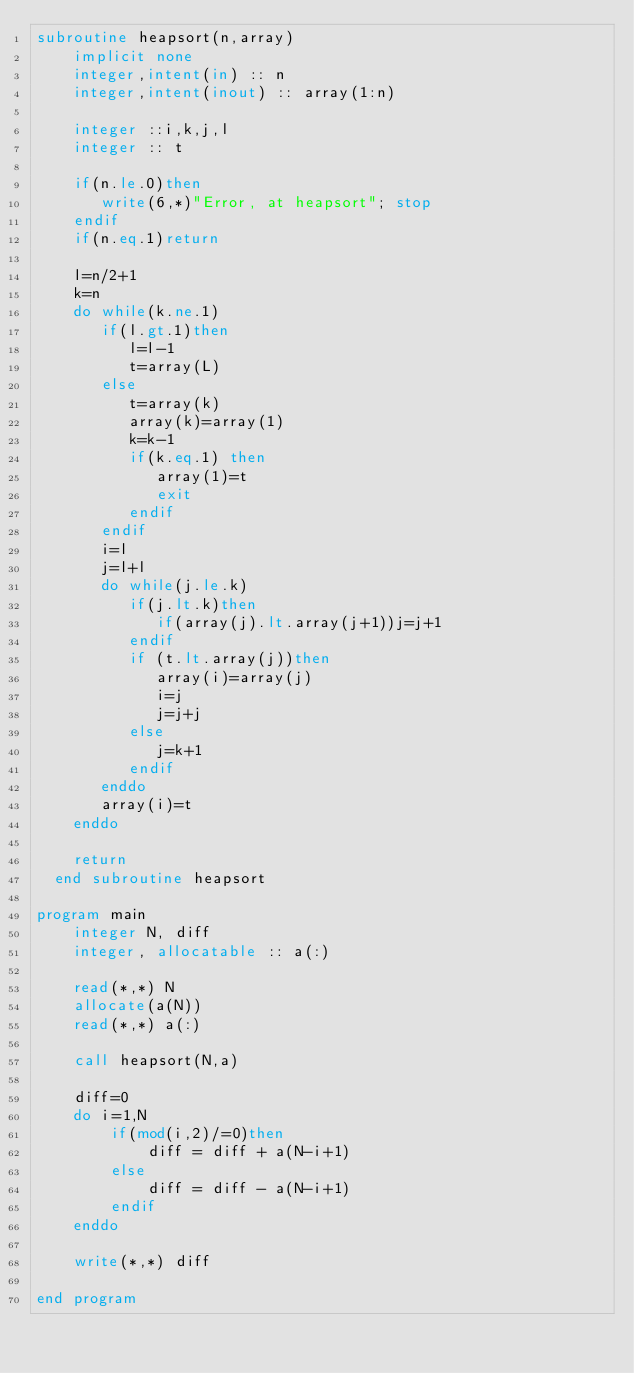Convert code to text. <code><loc_0><loc_0><loc_500><loc_500><_FORTRAN_>subroutine heapsort(n,array)
    implicit none
    integer,intent(in) :: n
    integer,intent(inout) :: array(1:n)
    
    integer ::i,k,j,l
    integer :: t
    
    if(n.le.0)then
       write(6,*)"Error, at heapsort"; stop
    endif
    if(n.eq.1)return
  
    l=n/2+1
    k=n
    do while(k.ne.1)
       if(l.gt.1)then
          l=l-1
          t=array(L)
       else
          t=array(k)
          array(k)=array(1)
          k=k-1
          if(k.eq.1) then
             array(1)=t
             exit
          endif
       endif
       i=l
       j=l+l
       do while(j.le.k)
          if(j.lt.k)then
             if(array(j).lt.array(j+1))j=j+1
          endif
          if (t.lt.array(j))then
             array(i)=array(j)
             i=j
             j=j+j
          else
             j=k+1
          endif
       enddo
       array(i)=t
    enddo
  
    return
  end subroutine heapsort

program main
    integer N, diff
    integer, allocatable :: a(:)

    read(*,*) N
    allocate(a(N))
    read(*,*) a(:)

    call heapsort(N,a)

    diff=0
    do i=1,N
        if(mod(i,2)/=0)then
            diff = diff + a(N-i+1)
        else
            diff = diff - a(N-i+1)
        endif
    enddo

    write(*,*) diff
    
end program</code> 